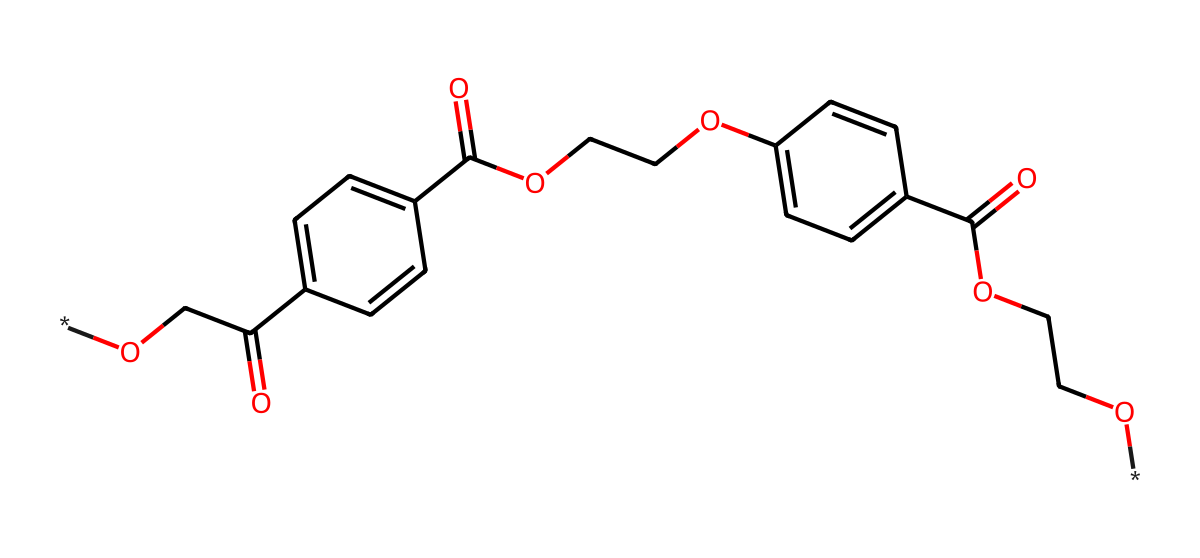How many carbon atoms are in the chemical structure? By examining the SMILES representation, count the number of carbon (C) symbols. This chemical contains multiple aromatic rings and aliphatic chains, leading to a total count of carbon atoms.
Answer: fourteen What functional groups are present in this chemical? Analyze the structure and identify common functional groups. In this chemical, there are ester (OCC(=O)), hydroxyl (C(=O)O), and ether (OCCO) groups, which are indicative of its properties.
Answer: ester, hydroxyl, ether What is the molecular formula of this compound? To determine the molecular formula, you need to count all the atoms represented in the chemical structure. By compiling the counts of carbon, hydrogen, and oxygen, the molecular formula is derived. This leads to C14H14O6.
Answer: C14H14O6 How many rings are present in the chemical structure? Count the number of cyclic structures (rings) present within the SMILES representation. Upon analysis, there are two benzene rings represented in the chemical structure.
Answer: two Is this chemical polar or non-polar? Assess the distribution of polar and non-polar groups. The presence of hydroxyl and ester groups indicates that the molecule has polar characteristics. Thus, it is classified as polar.
Answer: polar What type of polymer is represented by this structure? The chemical structure indicates a polymer due to the repeating units (monomers) within the ester linkages. Specifically, this is a type of polyester known as polyethylene terephthalate (PET).
Answer: polyester 